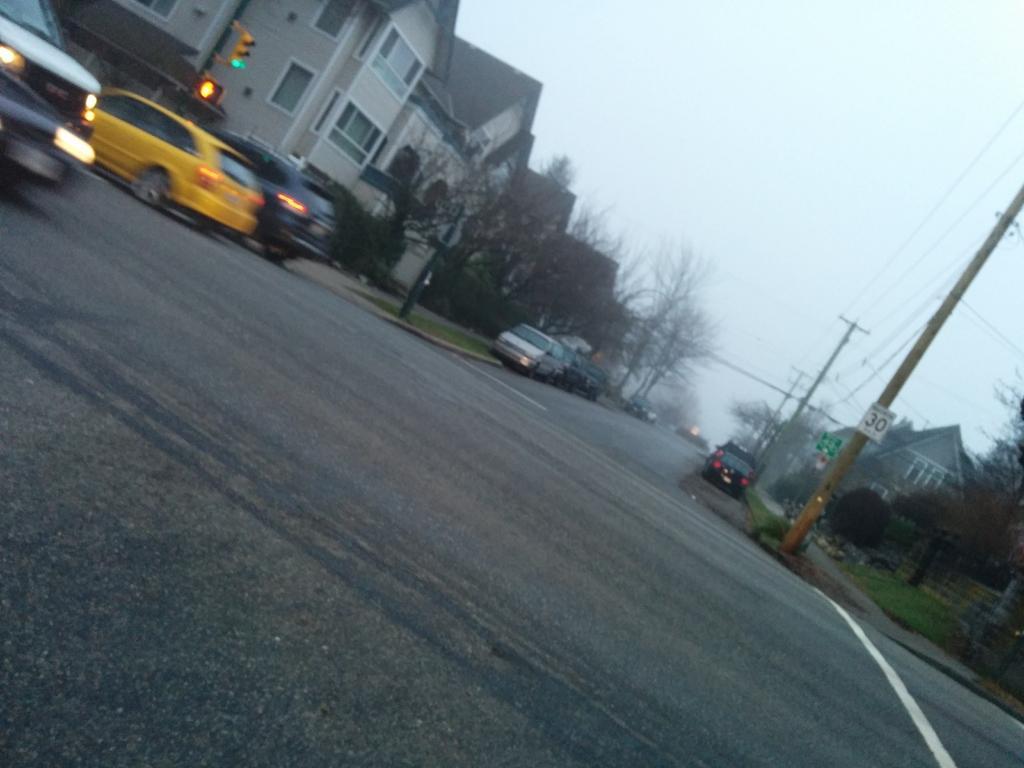Could you give a brief overview of what you see in this image? There are some cars parked on the road as we can see in the middle of this image. There are some trees and buildings in the background. There are some current polls on the right side of this image and there is a sky at the top of this image. 